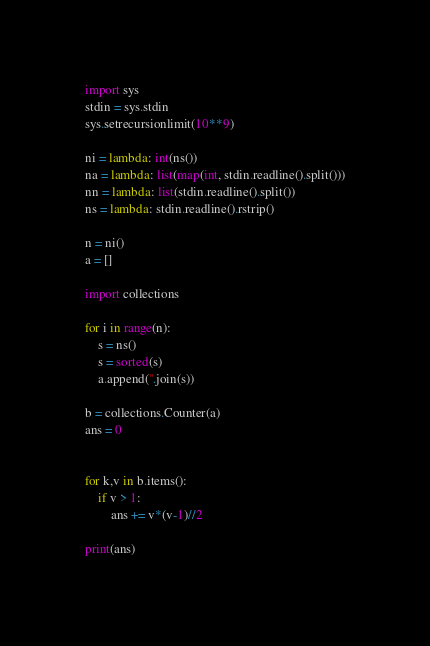Convert code to text. <code><loc_0><loc_0><loc_500><loc_500><_Python_>import sys
stdin = sys.stdin
sys.setrecursionlimit(10**9)
 
ni = lambda: int(ns())
na = lambda: list(map(int, stdin.readline().split()))
nn = lambda: list(stdin.readline().split())
ns = lambda: stdin.readline().rstrip()

n = ni()
a = []

import collections

for i in range(n):
    s = ns()
    s = sorted(s)
    a.append(''.join(s))

b = collections.Counter(a)
ans = 0


for k,v in b.items():
    if v > 1:
        ans += v*(v-1)//2

print(ans)
</code> 